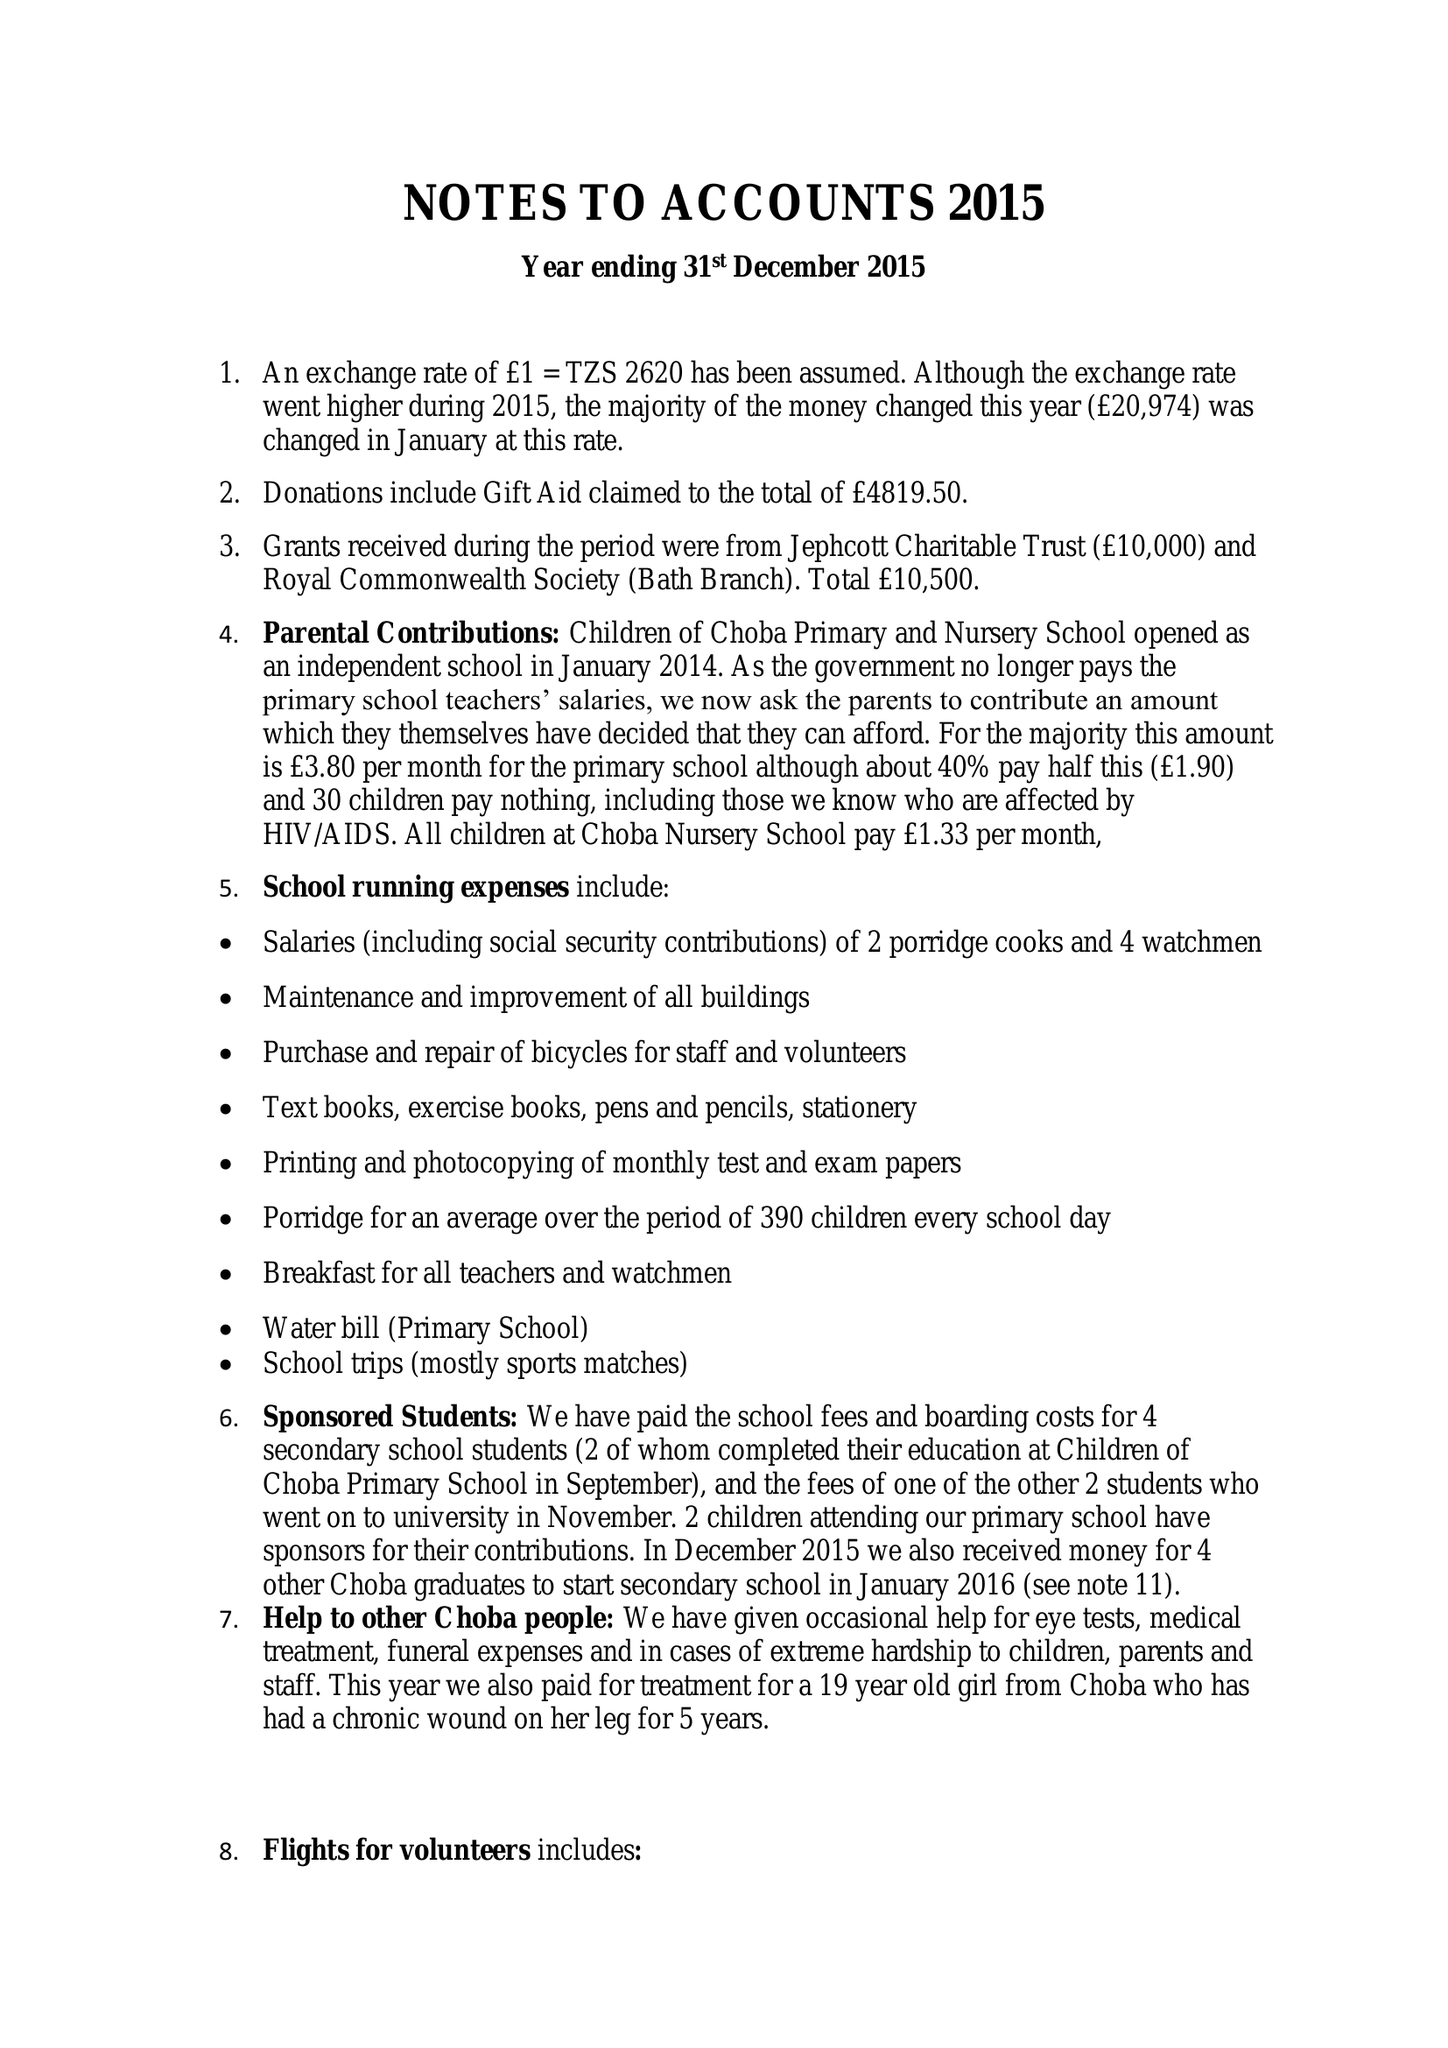What is the value for the income_annually_in_british_pounds?
Answer the question using a single word or phrase. 48375.00 